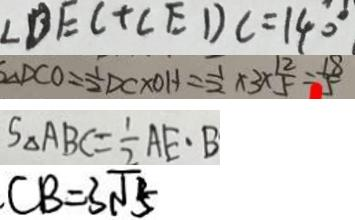Convert formula to latex. <formula><loc_0><loc_0><loc_500><loc_500>\angle D E C + \angle E D C = 1 4 0 ^ { \circ } 
 S \Delta D C O = \frac { 1 } { 2 } D C \times O H = \frac { 1 } { 2 } \times 3 \times \frac { 1 2 } { 5 } = \frac { 1 8 } { 5 } 
 S _ { \Delta } A B C = \frac { 1 } { 2 } A E \cdot B 
 C B = 3 \sqrt { 5 }</formula> 